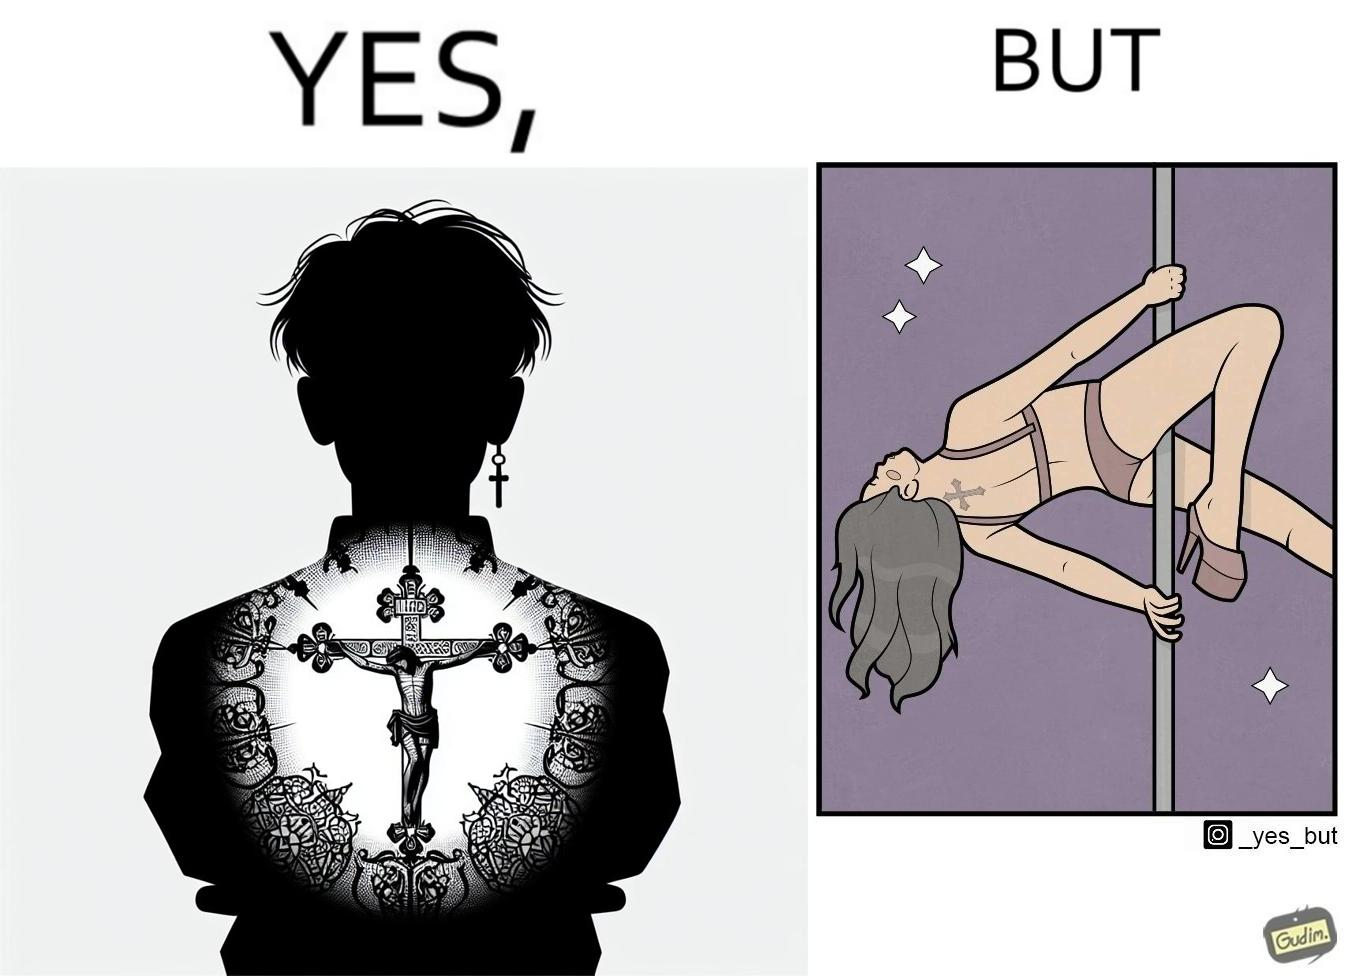Compare the left and right sides of this image. In the left part of the image: a tatto of holy cross symbol on the back of a girl,maybe she follows christianity as her religion In the right part of the image: a pole dancer performing, having a tatto of holy cross symbol on her back 